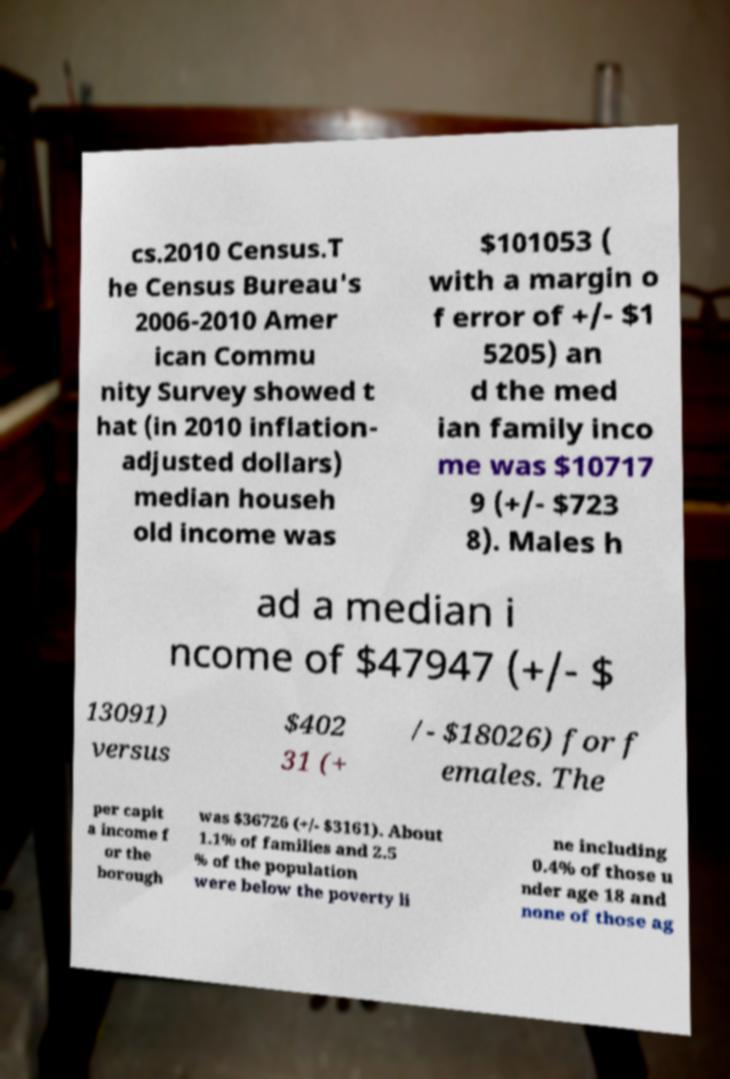What messages or text are displayed in this image? I need them in a readable, typed format. cs.2010 Census.T he Census Bureau's 2006-2010 Amer ican Commu nity Survey showed t hat (in 2010 inflation- adjusted dollars) median househ old income was $101053 ( with a margin o f error of +/- $1 5205) an d the med ian family inco me was $10717 9 (+/- $723 8). Males h ad a median i ncome of $47947 (+/- $ 13091) versus $402 31 (+ /- $18026) for f emales. The per capit a income f or the borough was $36726 (+/- $3161). About 1.1% of families and 2.5 % of the population were below the poverty li ne including 0.4% of those u nder age 18 and none of those ag 